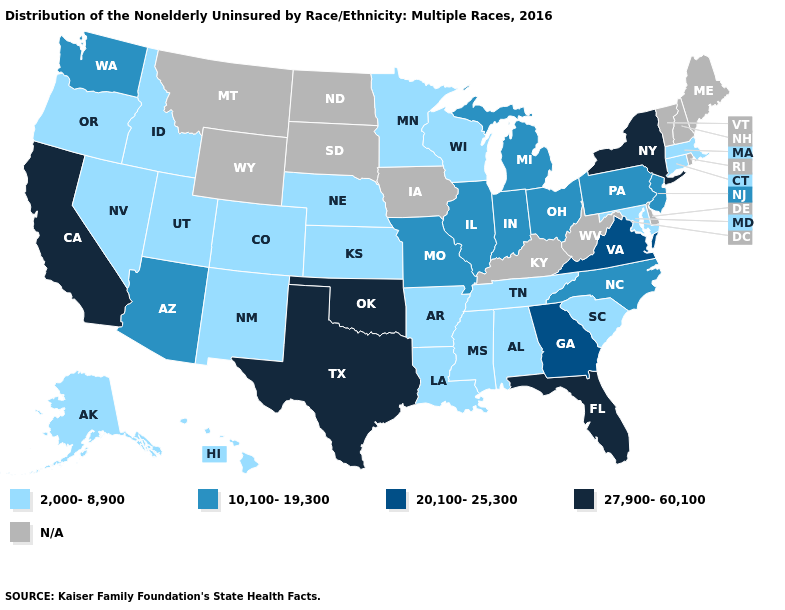Name the states that have a value in the range 2,000-8,900?
Quick response, please. Alabama, Alaska, Arkansas, Colorado, Connecticut, Hawaii, Idaho, Kansas, Louisiana, Maryland, Massachusetts, Minnesota, Mississippi, Nebraska, Nevada, New Mexico, Oregon, South Carolina, Tennessee, Utah, Wisconsin. What is the value of Maine?
Concise answer only. N/A. Which states hav the highest value in the MidWest?
Quick response, please. Illinois, Indiana, Michigan, Missouri, Ohio. How many symbols are there in the legend?
Concise answer only. 5. What is the value of Michigan?
Write a very short answer. 10,100-19,300. What is the lowest value in states that border Ohio?
Short answer required. 10,100-19,300. What is the lowest value in the USA?
Concise answer only. 2,000-8,900. What is the value of Missouri?
Be succinct. 10,100-19,300. Does the first symbol in the legend represent the smallest category?
Write a very short answer. Yes. What is the value of Maryland?
Give a very brief answer. 2,000-8,900. Among the states that border Maryland , which have the highest value?
Short answer required. Virginia. Does the first symbol in the legend represent the smallest category?
Concise answer only. Yes. Name the states that have a value in the range 27,900-60,100?
Write a very short answer. California, Florida, New York, Oklahoma, Texas. Does Pennsylvania have the highest value in the Northeast?
Answer briefly. No. Among the states that border Arkansas , which have the highest value?
Give a very brief answer. Oklahoma, Texas. 